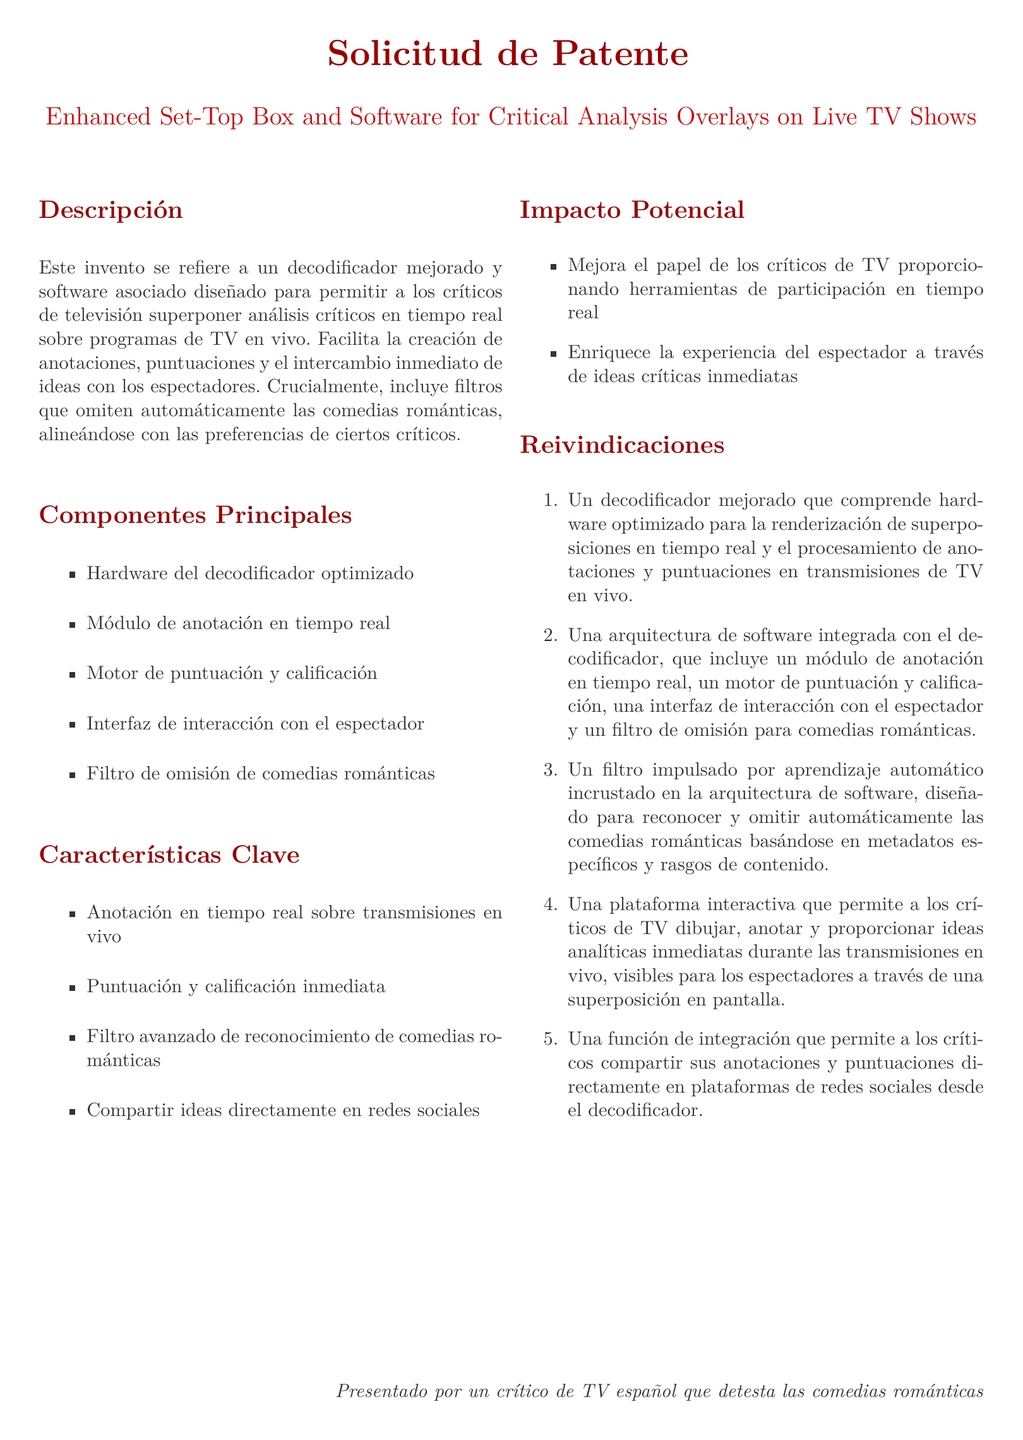¿Qué permite el decodificador mejorado? El decodificador mejorado permite superponer análisis críticos en tiempo real sobre programas de TV en vivo.
Answer: Superponer análisis críticos en tiempo real ¿Cuál es uno de los componentes principales del software? Uno de los componentes principales del software es el motor de puntuación y calificación.
Answer: Motor de puntuación y calificación ¿Qué tipo de comedias omite el filtro del decodificador? El filtro del decodificador omite automáticamente las comedias románticas.
Answer: Comedias románticas ¿Cuántas reivindicaciones hay en total? Hay cinco reivindicaciones en total.
Answer: Cinco ¿Cómo beneficia la plataforma a los críticos de TV? La plataforma beneficia a los críticos de TV al proporcionar herramientas de participación en tiempo real.
Answer: Herramientas de participación en tiempo real ¿Quién presentó la solicitud de patente? La solicitud de patente fue presentada por un crítico de TV español.
Answer: Un crítico de TV español 